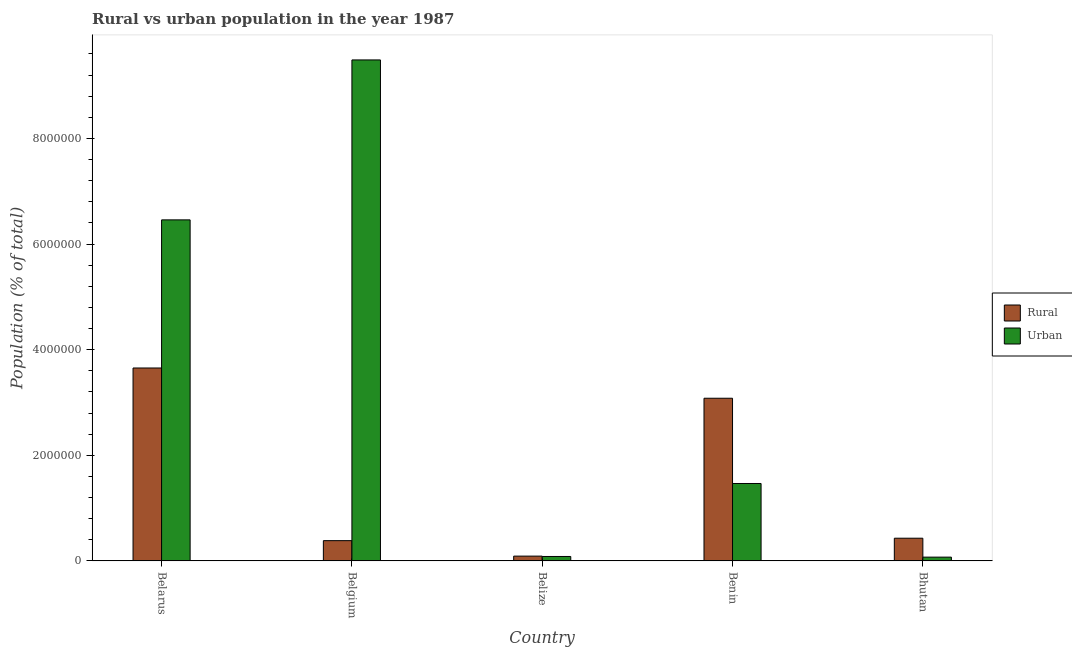How many different coloured bars are there?
Provide a succinct answer. 2. What is the label of the 3rd group of bars from the left?
Keep it short and to the point. Belize. In how many cases, is the number of bars for a given country not equal to the number of legend labels?
Offer a terse response. 0. What is the rural population density in Belize?
Your response must be concise. 9.06e+04. Across all countries, what is the maximum rural population density?
Offer a terse response. 3.65e+06. Across all countries, what is the minimum rural population density?
Make the answer very short. 9.06e+04. In which country was the urban population density minimum?
Make the answer very short. Bhutan. What is the total rural population density in the graph?
Offer a terse response. 7.64e+06. What is the difference between the urban population density in Belarus and that in Benin?
Keep it short and to the point. 4.99e+06. What is the difference between the urban population density in Belarus and the rural population density in Belize?
Provide a short and direct response. 6.37e+06. What is the average rural population density per country?
Ensure brevity in your answer.  1.53e+06. What is the difference between the rural population density and urban population density in Belgium?
Your answer should be very brief. -9.10e+06. In how many countries, is the rural population density greater than 400000 %?
Keep it short and to the point. 3. What is the ratio of the rural population density in Belarus to that in Benin?
Your answer should be very brief. 1.19. Is the difference between the rural population density in Belarus and Belgium greater than the difference between the urban population density in Belarus and Belgium?
Provide a short and direct response. Yes. What is the difference between the highest and the second highest urban population density?
Make the answer very short. 3.03e+06. What is the difference between the highest and the lowest rural population density?
Ensure brevity in your answer.  3.56e+06. In how many countries, is the urban population density greater than the average urban population density taken over all countries?
Give a very brief answer. 2. What does the 2nd bar from the left in Belize represents?
Offer a very short reply. Urban. What does the 2nd bar from the right in Benin represents?
Ensure brevity in your answer.  Rural. Are the values on the major ticks of Y-axis written in scientific E-notation?
Your answer should be compact. No. Does the graph contain grids?
Offer a very short reply. No. Where does the legend appear in the graph?
Your answer should be compact. Center right. How many legend labels are there?
Offer a very short reply. 2. How are the legend labels stacked?
Give a very brief answer. Vertical. What is the title of the graph?
Give a very brief answer. Rural vs urban population in the year 1987. What is the label or title of the Y-axis?
Make the answer very short. Population (% of total). What is the Population (% of total) in Rural in Belarus?
Ensure brevity in your answer.  3.65e+06. What is the Population (% of total) in Urban in Belarus?
Give a very brief answer. 6.46e+06. What is the Population (% of total) in Rural in Belgium?
Offer a terse response. 3.83e+05. What is the Population (% of total) of Urban in Belgium?
Your response must be concise. 9.49e+06. What is the Population (% of total) in Rural in Belize?
Give a very brief answer. 9.06e+04. What is the Population (% of total) of Urban in Belize?
Offer a terse response. 8.37e+04. What is the Population (% of total) in Rural in Benin?
Your answer should be very brief. 3.08e+06. What is the Population (% of total) in Urban in Benin?
Your answer should be very brief. 1.47e+06. What is the Population (% of total) of Rural in Bhutan?
Ensure brevity in your answer.  4.30e+05. What is the Population (% of total) of Urban in Bhutan?
Provide a short and direct response. 7.13e+04. Across all countries, what is the maximum Population (% of total) of Rural?
Keep it short and to the point. 3.65e+06. Across all countries, what is the maximum Population (% of total) of Urban?
Give a very brief answer. 9.49e+06. Across all countries, what is the minimum Population (% of total) in Rural?
Ensure brevity in your answer.  9.06e+04. Across all countries, what is the minimum Population (% of total) in Urban?
Your answer should be very brief. 7.13e+04. What is the total Population (% of total) of Rural in the graph?
Ensure brevity in your answer.  7.64e+06. What is the total Population (% of total) of Urban in the graph?
Ensure brevity in your answer.  1.76e+07. What is the difference between the Population (% of total) of Rural in Belarus and that in Belgium?
Provide a succinct answer. 3.27e+06. What is the difference between the Population (% of total) of Urban in Belarus and that in Belgium?
Make the answer very short. -3.03e+06. What is the difference between the Population (% of total) in Rural in Belarus and that in Belize?
Your answer should be very brief. 3.56e+06. What is the difference between the Population (% of total) in Urban in Belarus and that in Belize?
Your answer should be compact. 6.37e+06. What is the difference between the Population (% of total) of Rural in Belarus and that in Benin?
Provide a succinct answer. 5.73e+05. What is the difference between the Population (% of total) in Urban in Belarus and that in Benin?
Your response must be concise. 4.99e+06. What is the difference between the Population (% of total) of Rural in Belarus and that in Bhutan?
Offer a terse response. 3.22e+06. What is the difference between the Population (% of total) in Urban in Belarus and that in Bhutan?
Offer a terse response. 6.39e+06. What is the difference between the Population (% of total) in Rural in Belgium and that in Belize?
Offer a very short reply. 2.93e+05. What is the difference between the Population (% of total) in Urban in Belgium and that in Belize?
Your response must be concise. 9.40e+06. What is the difference between the Population (% of total) of Rural in Belgium and that in Benin?
Your response must be concise. -2.70e+06. What is the difference between the Population (% of total) of Urban in Belgium and that in Benin?
Provide a short and direct response. 8.02e+06. What is the difference between the Population (% of total) of Rural in Belgium and that in Bhutan?
Give a very brief answer. -4.62e+04. What is the difference between the Population (% of total) in Urban in Belgium and that in Bhutan?
Your answer should be very brief. 9.42e+06. What is the difference between the Population (% of total) of Rural in Belize and that in Benin?
Your answer should be very brief. -2.99e+06. What is the difference between the Population (% of total) in Urban in Belize and that in Benin?
Provide a short and direct response. -1.38e+06. What is the difference between the Population (% of total) of Rural in Belize and that in Bhutan?
Offer a very short reply. -3.39e+05. What is the difference between the Population (% of total) of Urban in Belize and that in Bhutan?
Your answer should be very brief. 1.24e+04. What is the difference between the Population (% of total) in Rural in Benin and that in Bhutan?
Ensure brevity in your answer.  2.65e+06. What is the difference between the Population (% of total) in Urban in Benin and that in Bhutan?
Provide a short and direct response. 1.39e+06. What is the difference between the Population (% of total) of Rural in Belarus and the Population (% of total) of Urban in Belgium?
Your answer should be very brief. -5.83e+06. What is the difference between the Population (% of total) in Rural in Belarus and the Population (% of total) in Urban in Belize?
Your response must be concise. 3.57e+06. What is the difference between the Population (% of total) in Rural in Belarus and the Population (% of total) in Urban in Benin?
Offer a very short reply. 2.19e+06. What is the difference between the Population (% of total) in Rural in Belarus and the Population (% of total) in Urban in Bhutan?
Offer a very short reply. 3.58e+06. What is the difference between the Population (% of total) in Rural in Belgium and the Population (% of total) in Urban in Belize?
Make the answer very short. 3.00e+05. What is the difference between the Population (% of total) of Rural in Belgium and the Population (% of total) of Urban in Benin?
Your answer should be very brief. -1.08e+06. What is the difference between the Population (% of total) of Rural in Belgium and the Population (% of total) of Urban in Bhutan?
Ensure brevity in your answer.  3.12e+05. What is the difference between the Population (% of total) in Rural in Belize and the Population (% of total) in Urban in Benin?
Your answer should be very brief. -1.38e+06. What is the difference between the Population (% of total) in Rural in Belize and the Population (% of total) in Urban in Bhutan?
Your answer should be very brief. 1.92e+04. What is the difference between the Population (% of total) of Rural in Benin and the Population (% of total) of Urban in Bhutan?
Give a very brief answer. 3.01e+06. What is the average Population (% of total) of Rural per country?
Provide a succinct answer. 1.53e+06. What is the average Population (% of total) of Urban per country?
Your answer should be compact. 3.51e+06. What is the difference between the Population (% of total) of Rural and Population (% of total) of Urban in Belarus?
Provide a succinct answer. -2.80e+06. What is the difference between the Population (% of total) of Rural and Population (% of total) of Urban in Belgium?
Your answer should be very brief. -9.10e+06. What is the difference between the Population (% of total) in Rural and Population (% of total) in Urban in Belize?
Offer a very short reply. 6844. What is the difference between the Population (% of total) in Rural and Population (% of total) in Urban in Benin?
Provide a succinct answer. 1.61e+06. What is the difference between the Population (% of total) of Rural and Population (% of total) of Urban in Bhutan?
Your answer should be very brief. 3.58e+05. What is the ratio of the Population (% of total) of Rural in Belarus to that in Belgium?
Keep it short and to the point. 9.53. What is the ratio of the Population (% of total) of Urban in Belarus to that in Belgium?
Provide a short and direct response. 0.68. What is the ratio of the Population (% of total) in Rural in Belarus to that in Belize?
Make the answer very short. 40.33. What is the ratio of the Population (% of total) in Urban in Belarus to that in Belize?
Ensure brevity in your answer.  77.12. What is the ratio of the Population (% of total) of Rural in Belarus to that in Benin?
Offer a very short reply. 1.19. What is the ratio of the Population (% of total) in Urban in Belarus to that in Benin?
Ensure brevity in your answer.  4.41. What is the ratio of the Population (% of total) in Rural in Belarus to that in Bhutan?
Provide a short and direct response. 8.5. What is the ratio of the Population (% of total) of Urban in Belarus to that in Bhutan?
Give a very brief answer. 90.53. What is the ratio of the Population (% of total) in Rural in Belgium to that in Belize?
Make the answer very short. 4.23. What is the ratio of the Population (% of total) of Urban in Belgium to that in Belize?
Your answer should be very brief. 113.29. What is the ratio of the Population (% of total) of Rural in Belgium to that in Benin?
Provide a short and direct response. 0.12. What is the ratio of the Population (% of total) in Urban in Belgium to that in Benin?
Provide a short and direct response. 6.47. What is the ratio of the Population (% of total) of Rural in Belgium to that in Bhutan?
Offer a terse response. 0.89. What is the ratio of the Population (% of total) of Urban in Belgium to that in Bhutan?
Offer a very short reply. 132.99. What is the ratio of the Population (% of total) of Rural in Belize to that in Benin?
Keep it short and to the point. 0.03. What is the ratio of the Population (% of total) of Urban in Belize to that in Benin?
Provide a succinct answer. 0.06. What is the ratio of the Population (% of total) in Rural in Belize to that in Bhutan?
Offer a very short reply. 0.21. What is the ratio of the Population (% of total) of Urban in Belize to that in Bhutan?
Make the answer very short. 1.17. What is the ratio of the Population (% of total) of Rural in Benin to that in Bhutan?
Your answer should be compact. 7.17. What is the ratio of the Population (% of total) of Urban in Benin to that in Bhutan?
Ensure brevity in your answer.  20.55. What is the difference between the highest and the second highest Population (% of total) in Rural?
Your answer should be very brief. 5.73e+05. What is the difference between the highest and the second highest Population (% of total) in Urban?
Provide a succinct answer. 3.03e+06. What is the difference between the highest and the lowest Population (% of total) in Rural?
Provide a short and direct response. 3.56e+06. What is the difference between the highest and the lowest Population (% of total) in Urban?
Provide a succinct answer. 9.42e+06. 